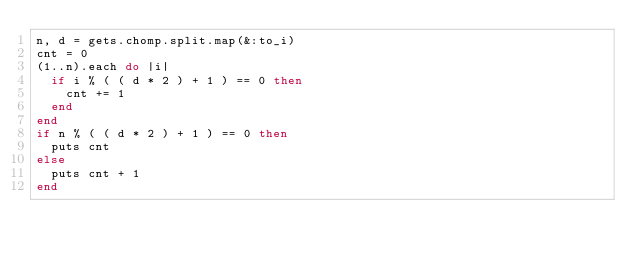<code> <loc_0><loc_0><loc_500><loc_500><_Ruby_>n, d = gets.chomp.split.map(&:to_i)
cnt = 0
(1..n).each do |i|
  if i % ( ( d * 2 ) + 1 ) == 0 then
    cnt += 1
  end
end
if n % ( ( d * 2 ) + 1 ) == 0 then
  puts cnt
else
  puts cnt + 1
end</code> 